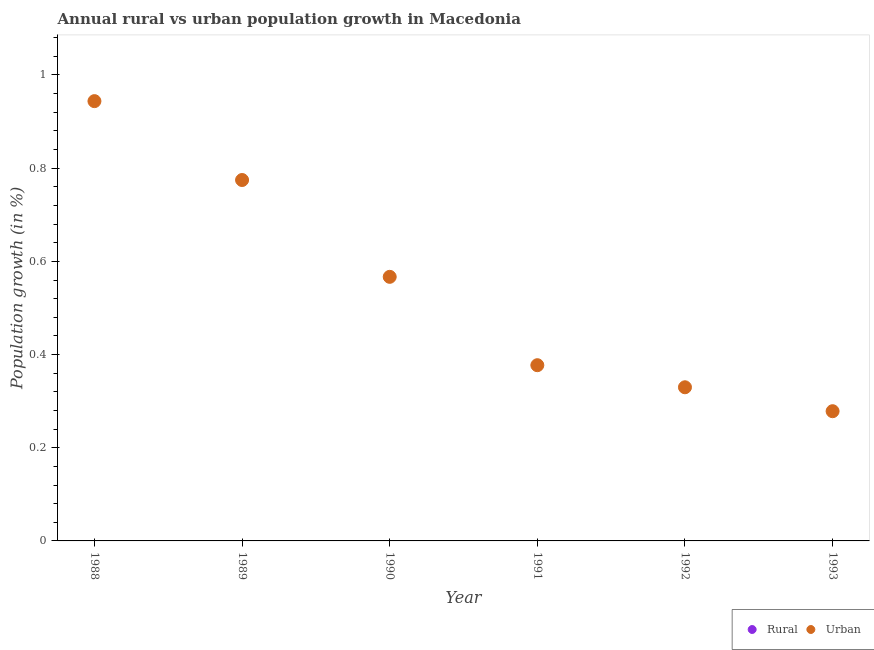Is the number of dotlines equal to the number of legend labels?
Give a very brief answer. No. What is the rural population growth in 1992?
Your response must be concise. 0. Across all years, what is the maximum urban population growth?
Offer a terse response. 0.94. Across all years, what is the minimum rural population growth?
Offer a terse response. 0. In which year was the urban population growth maximum?
Your response must be concise. 1988. What is the difference between the urban population growth in 1989 and that in 1991?
Ensure brevity in your answer.  0.4. What is the difference between the urban population growth in 1988 and the rural population growth in 1993?
Make the answer very short. 0.94. What is the average urban population growth per year?
Your response must be concise. 0.55. In how many years, is the urban population growth greater than 0.04 %?
Your answer should be compact. 6. What is the ratio of the urban population growth in 1989 to that in 1991?
Your answer should be very brief. 2.05. Is the urban population growth in 1989 less than that in 1993?
Your response must be concise. No. What is the difference between the highest and the second highest urban population growth?
Your response must be concise. 0.17. What is the difference between the highest and the lowest urban population growth?
Provide a succinct answer. 0.67. Does the rural population growth monotonically increase over the years?
Ensure brevity in your answer.  No. Is the rural population growth strictly greater than the urban population growth over the years?
Your response must be concise. No. Is the rural population growth strictly less than the urban population growth over the years?
Provide a succinct answer. Yes. How many dotlines are there?
Keep it short and to the point. 1. Are the values on the major ticks of Y-axis written in scientific E-notation?
Make the answer very short. No. How are the legend labels stacked?
Offer a very short reply. Horizontal. What is the title of the graph?
Your answer should be very brief. Annual rural vs urban population growth in Macedonia. Does "Foreign Liabilities" appear as one of the legend labels in the graph?
Offer a very short reply. No. What is the label or title of the X-axis?
Give a very brief answer. Year. What is the label or title of the Y-axis?
Keep it short and to the point. Population growth (in %). What is the Population growth (in %) of Urban  in 1988?
Keep it short and to the point. 0.94. What is the Population growth (in %) in Urban  in 1989?
Your answer should be very brief. 0.77. What is the Population growth (in %) in Rural in 1990?
Make the answer very short. 0. What is the Population growth (in %) of Urban  in 1990?
Provide a short and direct response. 0.57. What is the Population growth (in %) of Rural in 1991?
Provide a succinct answer. 0. What is the Population growth (in %) of Urban  in 1991?
Provide a succinct answer. 0.38. What is the Population growth (in %) of Urban  in 1992?
Make the answer very short. 0.33. What is the Population growth (in %) in Rural in 1993?
Give a very brief answer. 0. What is the Population growth (in %) of Urban  in 1993?
Ensure brevity in your answer.  0.28. Across all years, what is the maximum Population growth (in %) of Urban ?
Keep it short and to the point. 0.94. Across all years, what is the minimum Population growth (in %) in Urban ?
Make the answer very short. 0.28. What is the total Population growth (in %) in Rural in the graph?
Your answer should be compact. 0. What is the total Population growth (in %) in Urban  in the graph?
Your answer should be compact. 3.27. What is the difference between the Population growth (in %) of Urban  in 1988 and that in 1989?
Your answer should be very brief. 0.17. What is the difference between the Population growth (in %) of Urban  in 1988 and that in 1990?
Ensure brevity in your answer.  0.38. What is the difference between the Population growth (in %) of Urban  in 1988 and that in 1991?
Keep it short and to the point. 0.57. What is the difference between the Population growth (in %) in Urban  in 1988 and that in 1992?
Your response must be concise. 0.61. What is the difference between the Population growth (in %) of Urban  in 1988 and that in 1993?
Offer a terse response. 0.67. What is the difference between the Population growth (in %) of Urban  in 1989 and that in 1990?
Offer a terse response. 0.21. What is the difference between the Population growth (in %) in Urban  in 1989 and that in 1991?
Make the answer very short. 0.4. What is the difference between the Population growth (in %) in Urban  in 1989 and that in 1992?
Offer a terse response. 0.44. What is the difference between the Population growth (in %) of Urban  in 1989 and that in 1993?
Make the answer very short. 0.5. What is the difference between the Population growth (in %) of Urban  in 1990 and that in 1991?
Ensure brevity in your answer.  0.19. What is the difference between the Population growth (in %) of Urban  in 1990 and that in 1992?
Your answer should be compact. 0.24. What is the difference between the Population growth (in %) in Urban  in 1990 and that in 1993?
Keep it short and to the point. 0.29. What is the difference between the Population growth (in %) in Urban  in 1991 and that in 1992?
Provide a succinct answer. 0.05. What is the difference between the Population growth (in %) of Urban  in 1991 and that in 1993?
Your response must be concise. 0.1. What is the difference between the Population growth (in %) in Urban  in 1992 and that in 1993?
Make the answer very short. 0.05. What is the average Population growth (in %) in Rural per year?
Give a very brief answer. 0. What is the average Population growth (in %) in Urban  per year?
Your response must be concise. 0.55. What is the ratio of the Population growth (in %) of Urban  in 1988 to that in 1989?
Give a very brief answer. 1.22. What is the ratio of the Population growth (in %) in Urban  in 1988 to that in 1990?
Keep it short and to the point. 1.67. What is the ratio of the Population growth (in %) of Urban  in 1988 to that in 1991?
Provide a short and direct response. 2.5. What is the ratio of the Population growth (in %) of Urban  in 1988 to that in 1992?
Your answer should be compact. 2.86. What is the ratio of the Population growth (in %) of Urban  in 1988 to that in 1993?
Give a very brief answer. 3.39. What is the ratio of the Population growth (in %) of Urban  in 1989 to that in 1990?
Give a very brief answer. 1.37. What is the ratio of the Population growth (in %) of Urban  in 1989 to that in 1991?
Make the answer very short. 2.05. What is the ratio of the Population growth (in %) in Urban  in 1989 to that in 1992?
Your answer should be very brief. 2.35. What is the ratio of the Population growth (in %) of Urban  in 1989 to that in 1993?
Your response must be concise. 2.78. What is the ratio of the Population growth (in %) in Urban  in 1990 to that in 1991?
Your response must be concise. 1.5. What is the ratio of the Population growth (in %) of Urban  in 1990 to that in 1992?
Provide a short and direct response. 1.72. What is the ratio of the Population growth (in %) of Urban  in 1990 to that in 1993?
Give a very brief answer. 2.04. What is the ratio of the Population growth (in %) in Urban  in 1991 to that in 1992?
Offer a very short reply. 1.14. What is the ratio of the Population growth (in %) of Urban  in 1991 to that in 1993?
Give a very brief answer. 1.35. What is the ratio of the Population growth (in %) in Urban  in 1992 to that in 1993?
Ensure brevity in your answer.  1.18. What is the difference between the highest and the second highest Population growth (in %) in Urban ?
Your answer should be very brief. 0.17. What is the difference between the highest and the lowest Population growth (in %) in Urban ?
Your response must be concise. 0.67. 